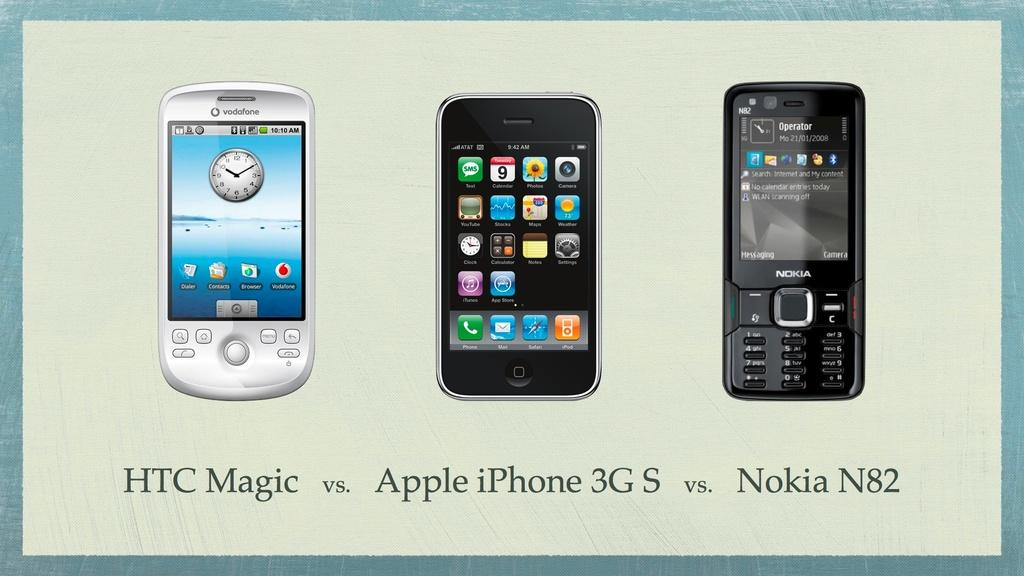<image>
Relay a brief, clear account of the picture shown. An ad for Apple iPhones shows three different phones. 